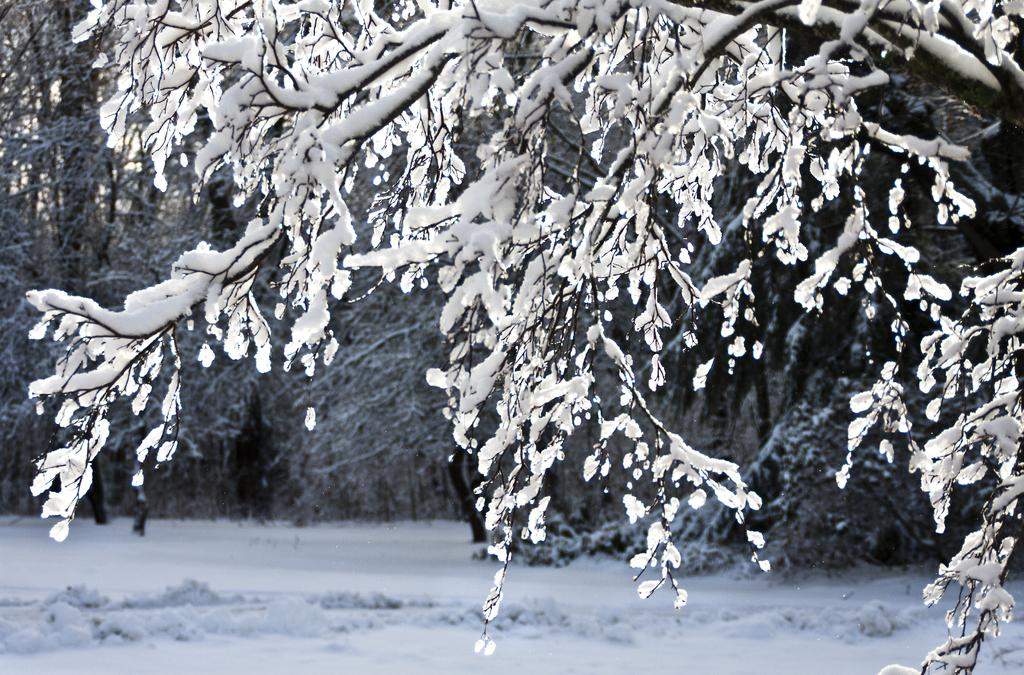What type of weather condition is depicted in the image? There is snow on the ground in the image, indicating a snowy weather condition. What can be seen in the background of the image? There are trees visible in the background of the image. What type of cable is visible in the image? There is no cable present in the image. What territory is depicted in the image? The image does not depict a specific territory; it simply shows snow on the ground and trees in the background. 